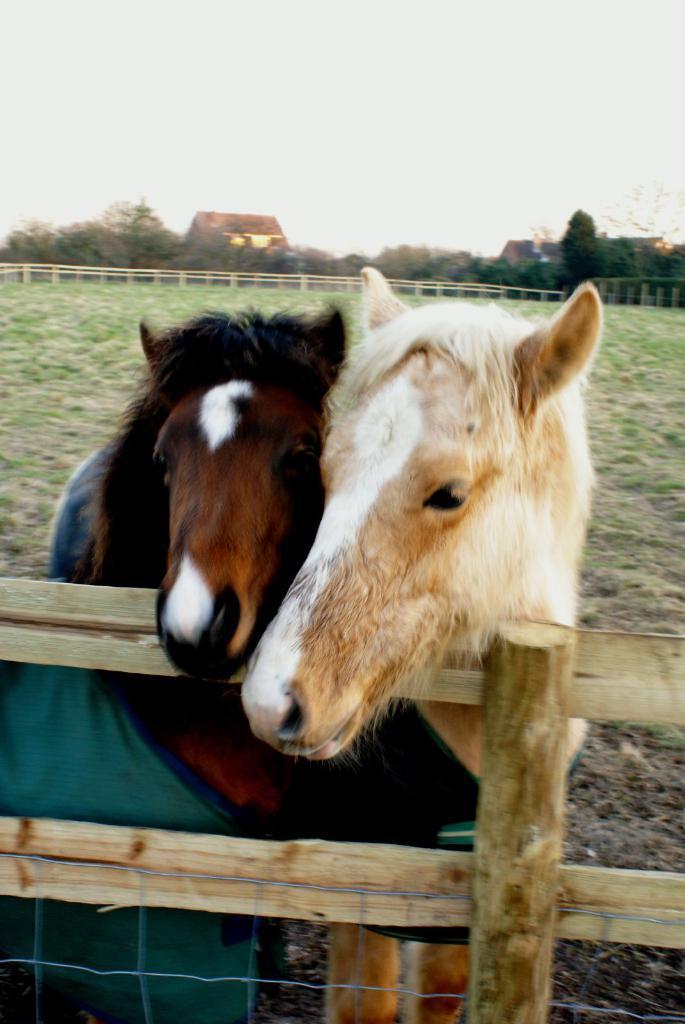Can you describe this image briefly? In this image we can see two horses near the wooden fence. In the background, we can see the grass, houses, trees and the sky. 